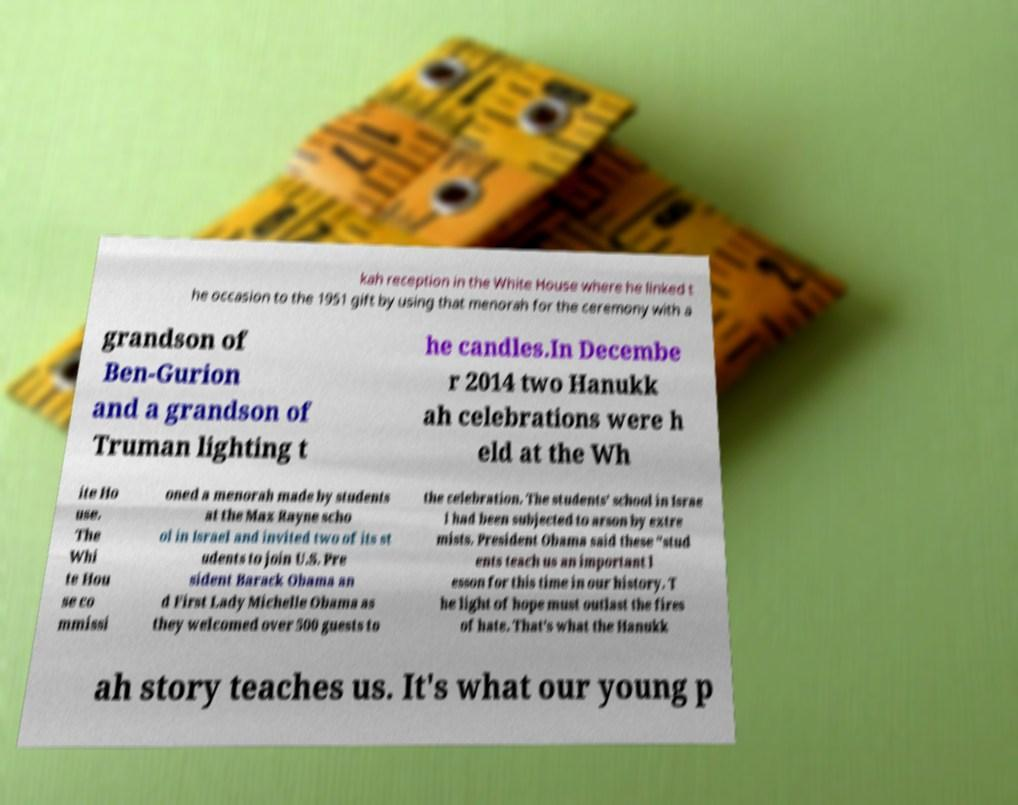Could you extract and type out the text from this image? kah reception in the White House where he linked t he occasion to the 1951 gift by using that menorah for the ceremony with a grandson of Ben-Gurion and a grandson of Truman lighting t he candles.In Decembe r 2014 two Hanukk ah celebrations were h eld at the Wh ite Ho use. The Whi te Hou se co mmissi oned a menorah made by students at the Max Rayne scho ol in Israel and invited two of its st udents to join U.S. Pre sident Barack Obama an d First Lady Michelle Obama as they welcomed over 500 guests to the celebration. The students' school in Israe l had been subjected to arson by extre mists. President Obama said these "stud ents teach us an important l esson for this time in our history. T he light of hope must outlast the fires of hate. That's what the Hanukk ah story teaches us. It's what our young p 